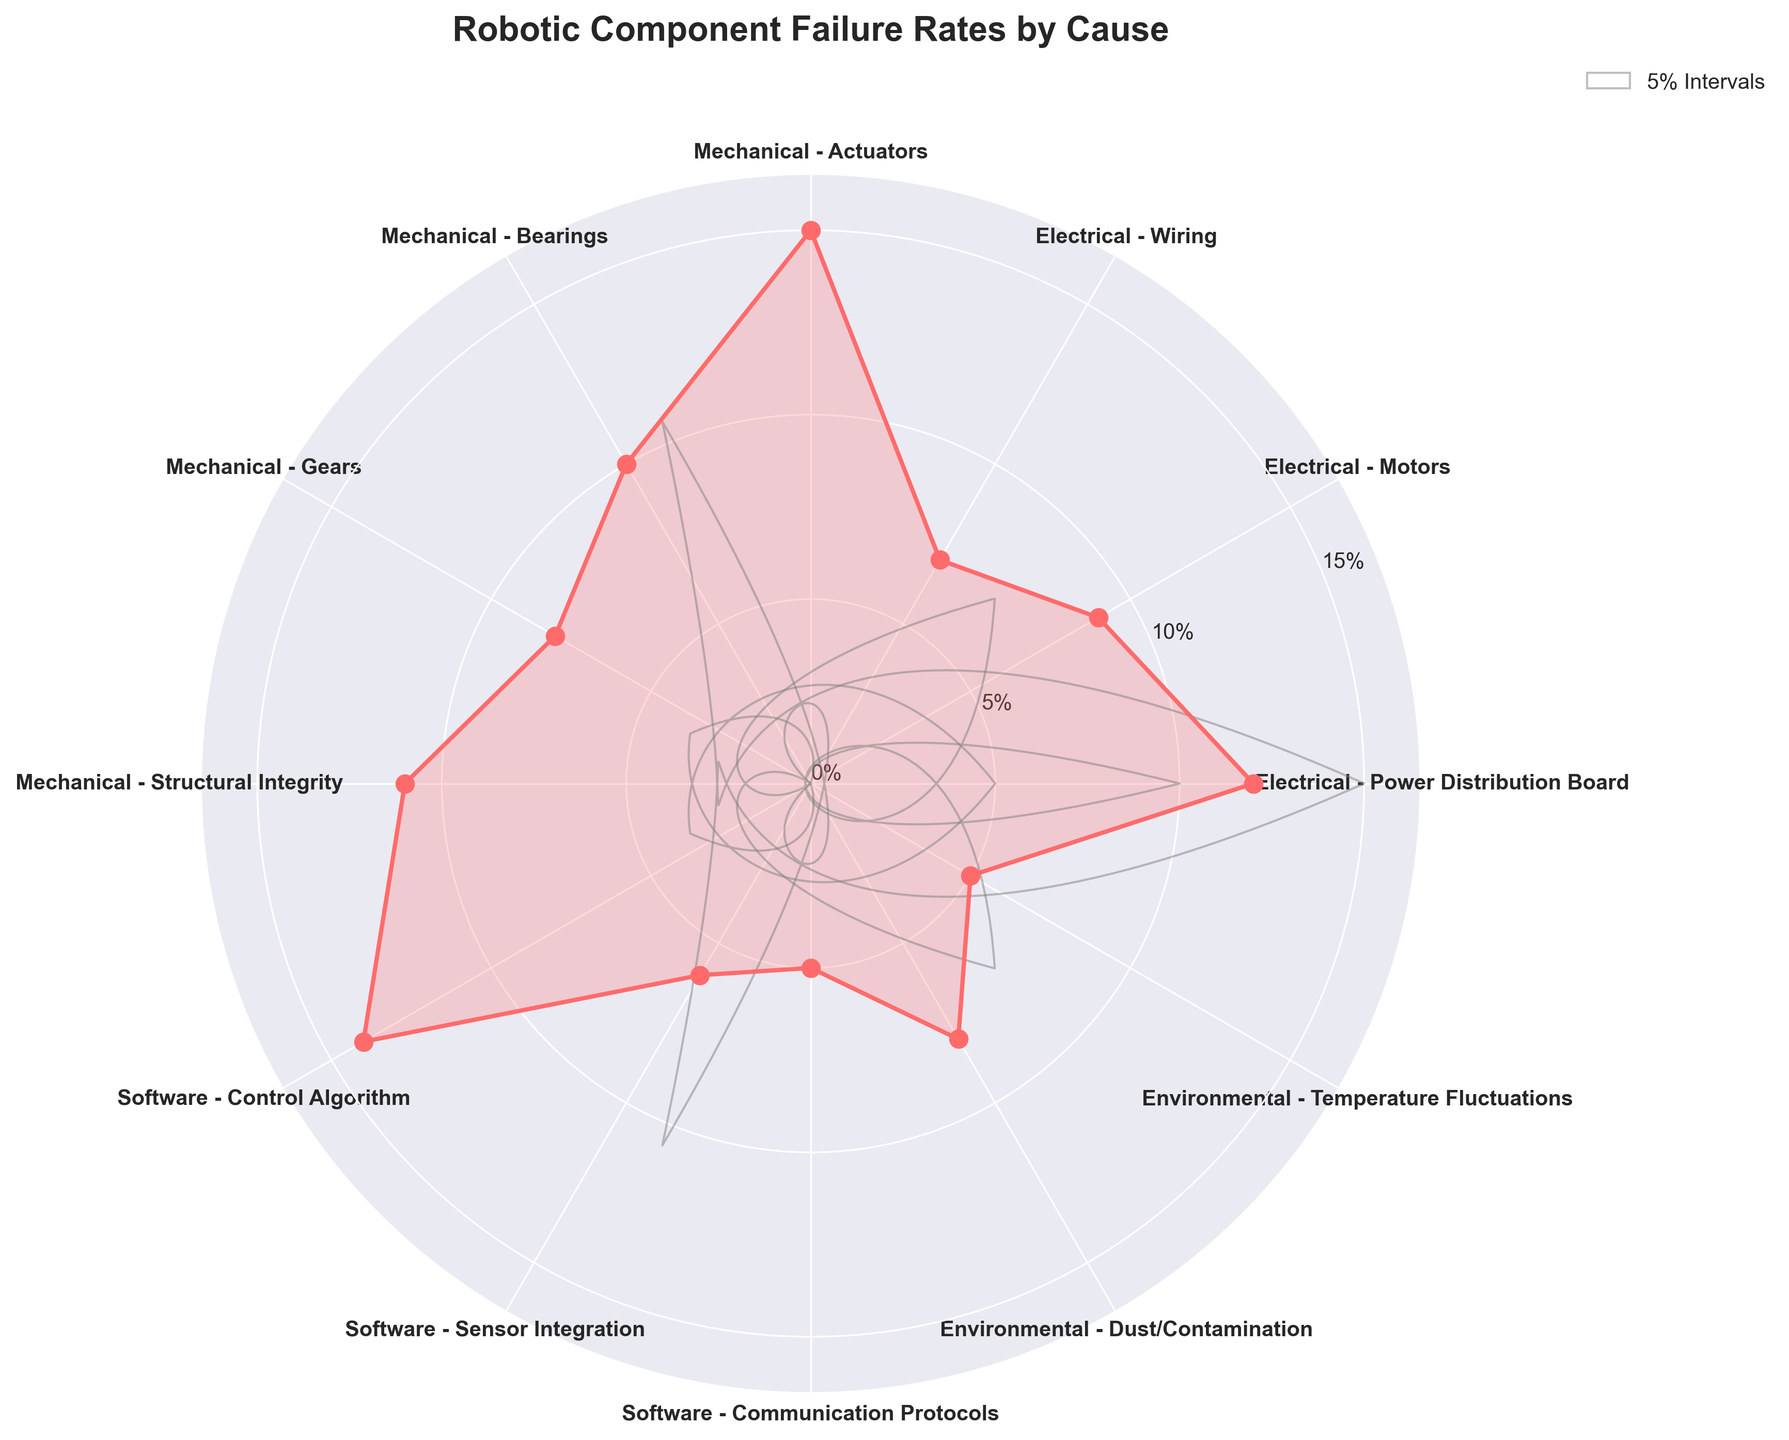What's the title of the figure? The title is typically positioned at the top of the chart and can often be found in a larger or bold font for emphasis.
Answer: Robotic Component Failure Rates by Cause What is the failure rate percentage for Mechanical - Actuators? Find the label "Mechanical - Actuators" around the polar plot and then look at the corresponding data point on the plot to read its failure rate.
Answer: 15% Which failure cause has the lowest failure rate percentage? Identify the smallest value on the radius axis and find the corresponding label at that angle on the polar plot.
Answer: Software - Communication Protocols How many causes are classified under Electrical issues? Look for all the segments with labels that start with "Electrical" and count them.
Answer: 3 What is the combined failure rate of causes categorized under Environmental issues? Identify the segments "Environmental - Dust/Contamination" and "Environmental - Temperature Fluctuations," then add their failure rates: 8% + 5%.
Answer: 13% Which failure cause has the highest failure rate percentage? Look for the segment that extends the furthest from the center and identify the corresponding label.
Answer: Mechanical - Actuators Which failure category has the highest total failure rate when summing all its causes? Sum the failure rates for each category: Electrical (12% + 9% + 7% = 28%), Mechanical (15% + 10% + 8% + 11% = 44%), Software (14% + 6% + 5% = 25%), Environmental (8% + 5% = 13%). Compare the totals.
Answer: Mechanical Compare and contrast the failure rates of Electrical - Motors and Software - Control Algorithm. Which one is higher? Identify the failure rate percentages for both labels and compare them: Electrical - Motors (9%) vs. Software - Control Algorithm (14%).
Answer: Software - Control Algorithm For Software failures, which cause has the lowest failure rate and by how much is it lower than the highest software failure cause? Identify the software failure rates and find the highest (14%, Control Algorithm) and the lowest (5%, Communication Protocols), then calculate the difference: 14% - 5%.
Answer: 9% What is the average failure rate for all the causes listed? Sum all the failure rates (12 + 9 + 7 + 15 + 10 + 8 + 11 + 14 + 6 + 5 + 8 + 5 = 110) and divide by the number of causes (12). Result: 110 / 12 ≈ 9.17%.
Answer: 9.17% 